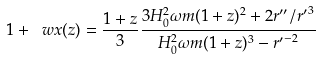<formula> <loc_0><loc_0><loc_500><loc_500>1 + \ w x ( z ) = \frac { 1 + z } { 3 } \frac { 3 H _ { 0 } ^ { 2 } \omega m ( 1 + z ) ^ { 2 } + 2 r ^ { \prime \prime } / { r ^ { \prime } } ^ { 3 } } { H _ { 0 } ^ { 2 } \omega m ( 1 + z ) ^ { 3 } - { r ^ { \prime } } ^ { - 2 } }</formula> 